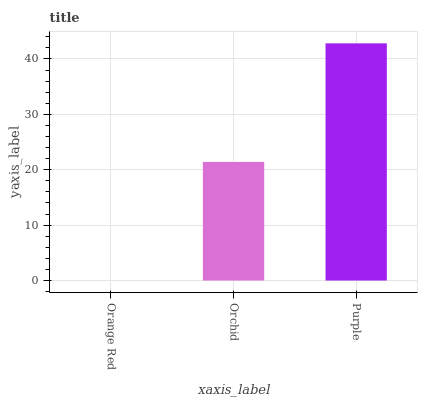Is Orchid the minimum?
Answer yes or no. No. Is Orchid the maximum?
Answer yes or no. No. Is Orchid greater than Orange Red?
Answer yes or no. Yes. Is Orange Red less than Orchid?
Answer yes or no. Yes. Is Orange Red greater than Orchid?
Answer yes or no. No. Is Orchid less than Orange Red?
Answer yes or no. No. Is Orchid the high median?
Answer yes or no. Yes. Is Orchid the low median?
Answer yes or no. Yes. Is Orange Red the high median?
Answer yes or no. No. Is Orange Red the low median?
Answer yes or no. No. 